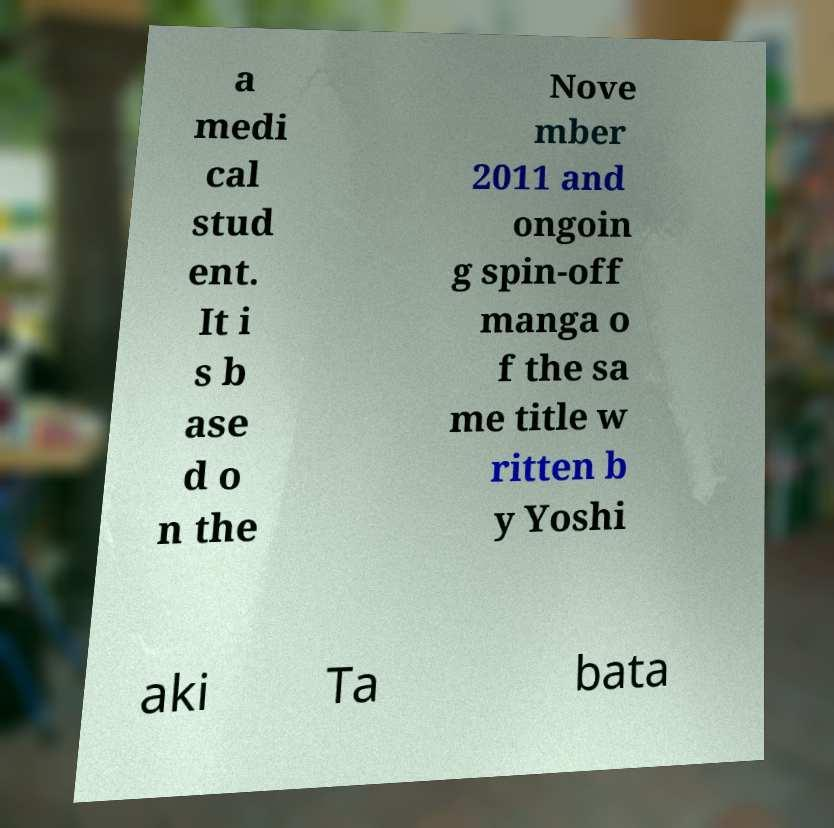I need the written content from this picture converted into text. Can you do that? a medi cal stud ent. It i s b ase d o n the Nove mber 2011 and ongoin g spin-off manga o f the sa me title w ritten b y Yoshi aki Ta bata 